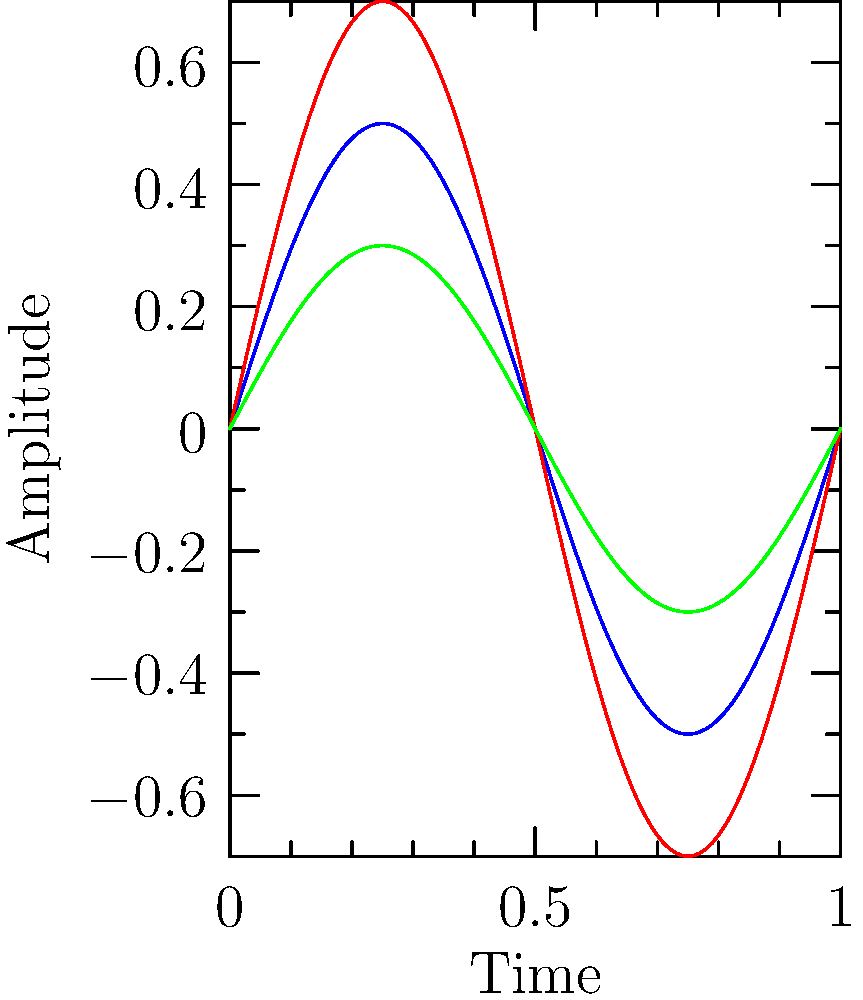Based on the sound wave patterns shown in the chart, which vinyl pressing is likely to have the highest audio fidelity compared to the original recording? To determine which vinyl pressing has the highest audio fidelity, we need to analyze the sound wave patterns:

1. The blue line represents the original recording.
2. The red line represents the 180g pressing.
3. The green line represents the picture disc pressing.

Step 1: Compare amplitudes
- The 180g pressing (red) has the highest amplitude.
- The picture disc (green) has the lowest amplitude.

Step 2: Analyze waveform similarity
- The 180g pressing closely follows the shape of the original waveform.
- The picture disc has a similar shape but with reduced amplitude.

Step 3: Consider vinyl characteristics
- 180g vinyl is known for its stability and ability to capture more detail.
- Picture discs often sacrifice some audio quality for visual appeal.

Step 4: Conclude based on observations
- The 180g pressing shows the most similar waveform to the original, with even higher amplitude, suggesting it can reproduce the original sound more accurately.

Therefore, the 180g pressing is likely to have the highest audio fidelity compared to the original recording.
Answer: 180g Pressing 